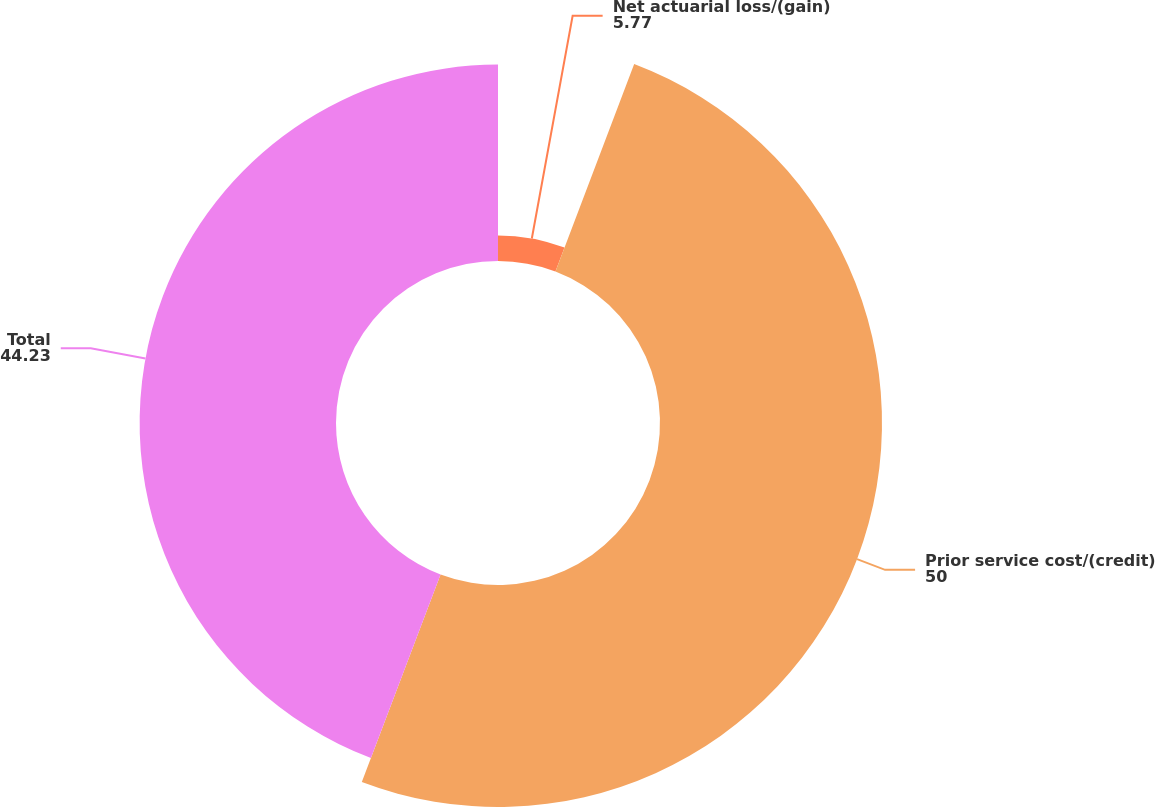Convert chart. <chart><loc_0><loc_0><loc_500><loc_500><pie_chart><fcel>Net actuarial loss/(gain)<fcel>Prior service cost/(credit)<fcel>Total<nl><fcel>5.77%<fcel>50.0%<fcel>44.23%<nl></chart> 